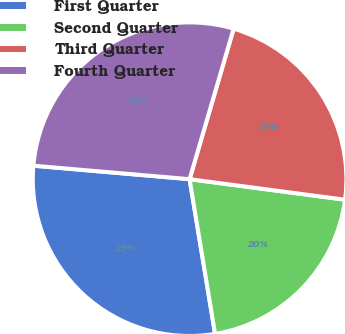Convert chart to OTSL. <chart><loc_0><loc_0><loc_500><loc_500><pie_chart><fcel>First Quarter<fcel>Second Quarter<fcel>Third Quarter<fcel>Fourth Quarter<nl><fcel>28.97%<fcel>20.31%<fcel>22.56%<fcel>28.16%<nl></chart> 